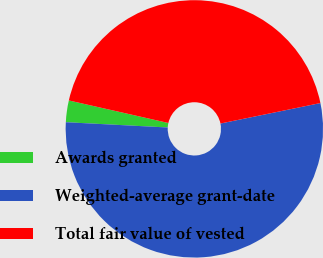<chart> <loc_0><loc_0><loc_500><loc_500><pie_chart><fcel>Awards granted<fcel>Weighted-average grant-date<fcel>Total fair value of vested<nl><fcel>2.72%<fcel>54.04%<fcel>43.24%<nl></chart> 